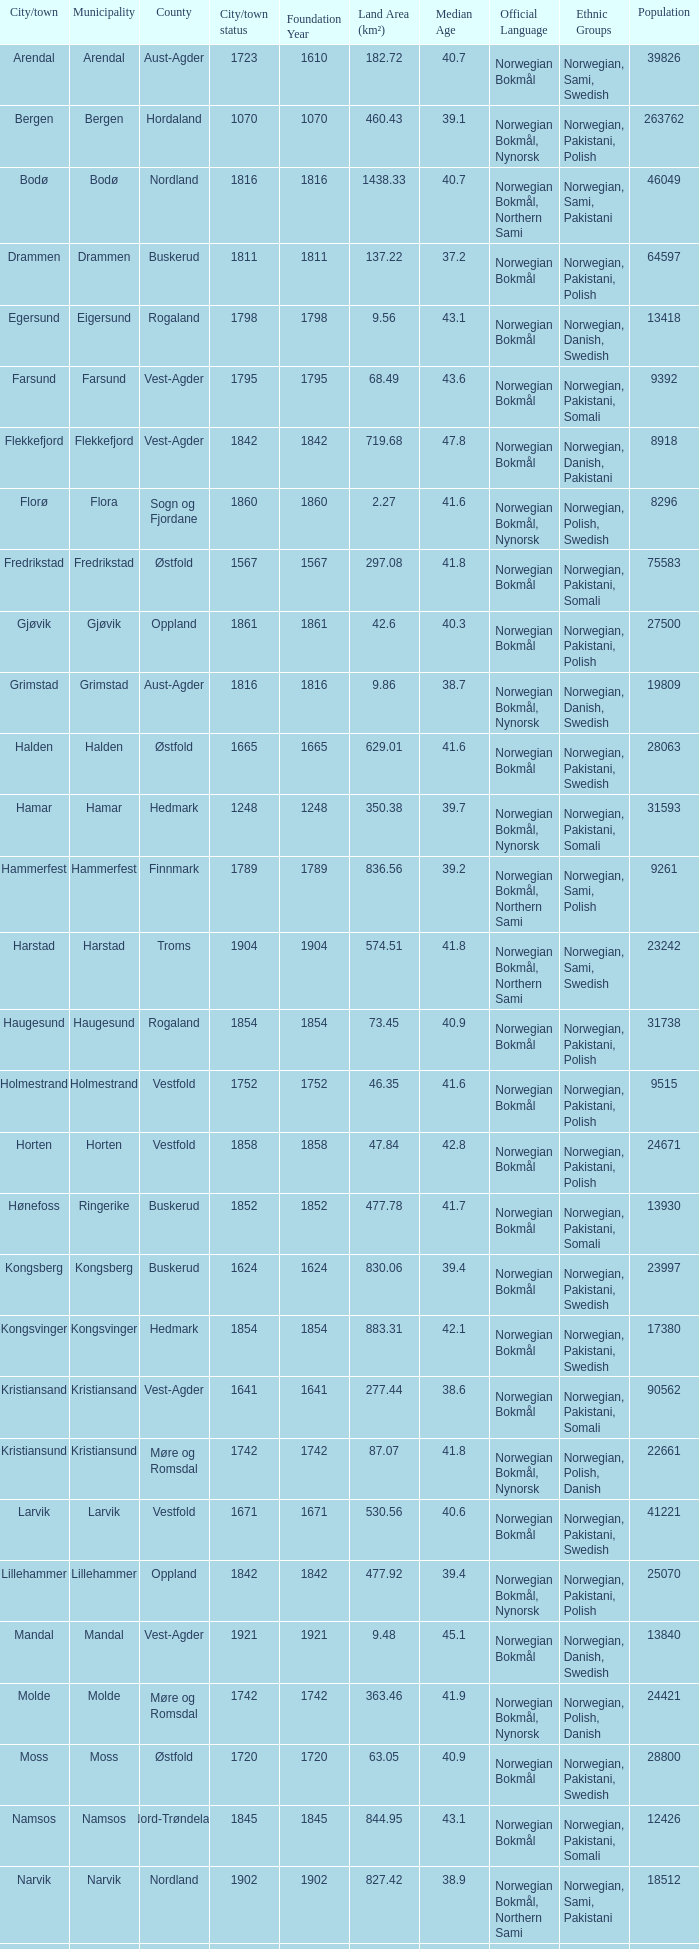What are the cities/towns located in the municipality of Moss? Moss. 